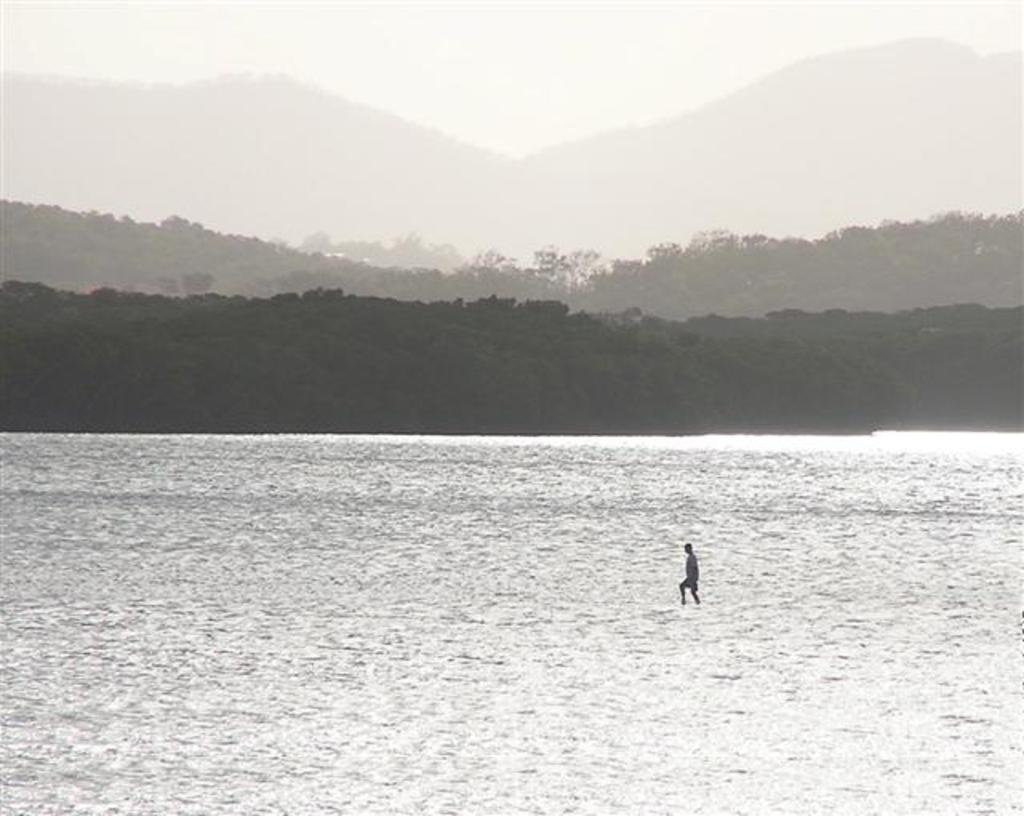What is the person in the image doing? There is a person in the water in the image. What can be seen in the background of the image? There are trees, mountains, and the sky visible in the background of the image. What brand of toothpaste is the person using in the image? There is no toothpaste present in the image, as the person is in the water. How many clocks can be seen in the image? There are no clocks visible in the image; the focus is on the person in the water and the background elements. 